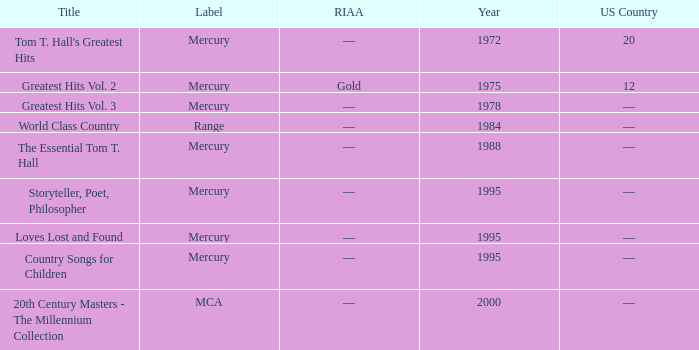What label had the album after 1978? Range, Mercury, Mercury, Mercury, Mercury, MCA. 